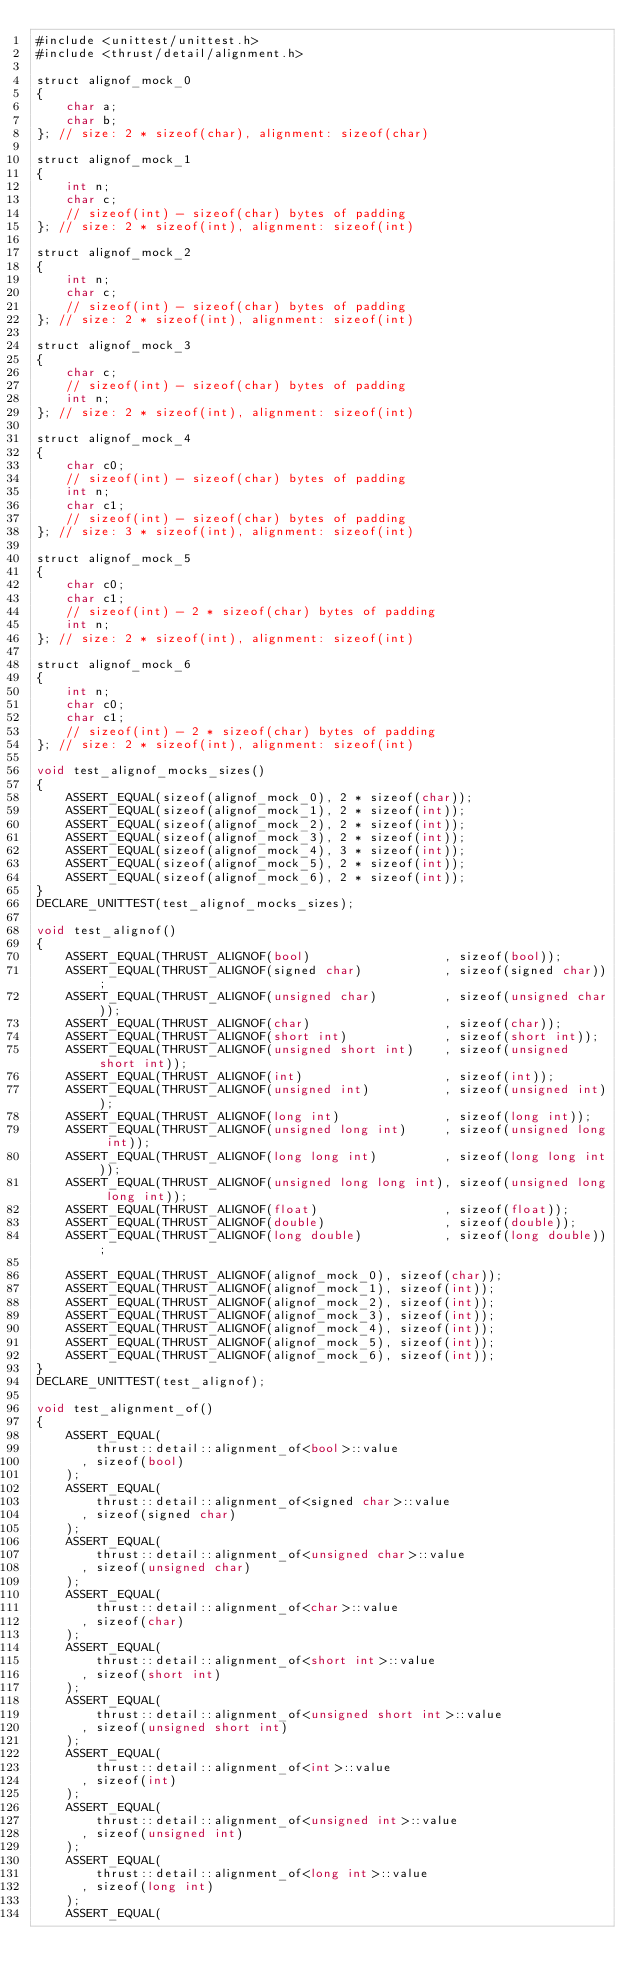<code> <loc_0><loc_0><loc_500><loc_500><_Cuda_>#include <unittest/unittest.h>
#include <thrust/detail/alignment.h>

struct alignof_mock_0
{
    char a;
    char b;
}; // size: 2 * sizeof(char), alignment: sizeof(char)

struct alignof_mock_1
{
    int n;
    char c;
    // sizeof(int) - sizeof(char) bytes of padding
}; // size: 2 * sizeof(int), alignment: sizeof(int)

struct alignof_mock_2
{
    int n;
    char c;
    // sizeof(int) - sizeof(char) bytes of padding
}; // size: 2 * sizeof(int), alignment: sizeof(int)

struct alignof_mock_3
{
    char c;
    // sizeof(int) - sizeof(char) bytes of padding
    int n;
}; // size: 2 * sizeof(int), alignment: sizeof(int)

struct alignof_mock_4
{
    char c0;
    // sizeof(int) - sizeof(char) bytes of padding
    int n;
    char c1;
    // sizeof(int) - sizeof(char) bytes of padding
}; // size: 3 * sizeof(int), alignment: sizeof(int)

struct alignof_mock_5
{
    char c0;
    char c1;
    // sizeof(int) - 2 * sizeof(char) bytes of padding
    int n;
}; // size: 2 * sizeof(int), alignment: sizeof(int)

struct alignof_mock_6
{
    int n;
    char c0;
    char c1;
    // sizeof(int) - 2 * sizeof(char) bytes of padding
}; // size: 2 * sizeof(int), alignment: sizeof(int)

void test_alignof_mocks_sizes()
{
    ASSERT_EQUAL(sizeof(alignof_mock_0), 2 * sizeof(char));
    ASSERT_EQUAL(sizeof(alignof_mock_1), 2 * sizeof(int));
    ASSERT_EQUAL(sizeof(alignof_mock_2), 2 * sizeof(int));
    ASSERT_EQUAL(sizeof(alignof_mock_3), 2 * sizeof(int));
    ASSERT_EQUAL(sizeof(alignof_mock_4), 3 * sizeof(int));
    ASSERT_EQUAL(sizeof(alignof_mock_5), 2 * sizeof(int));
    ASSERT_EQUAL(sizeof(alignof_mock_6), 2 * sizeof(int));
}
DECLARE_UNITTEST(test_alignof_mocks_sizes);

void test_alignof()
{
    ASSERT_EQUAL(THRUST_ALIGNOF(bool)                  , sizeof(bool));
    ASSERT_EQUAL(THRUST_ALIGNOF(signed char)           , sizeof(signed char));
    ASSERT_EQUAL(THRUST_ALIGNOF(unsigned char)         , sizeof(unsigned char));
    ASSERT_EQUAL(THRUST_ALIGNOF(char)                  , sizeof(char));
    ASSERT_EQUAL(THRUST_ALIGNOF(short int)             , sizeof(short int));
    ASSERT_EQUAL(THRUST_ALIGNOF(unsigned short int)    , sizeof(unsigned short int));
    ASSERT_EQUAL(THRUST_ALIGNOF(int)                   , sizeof(int));
    ASSERT_EQUAL(THRUST_ALIGNOF(unsigned int)          , sizeof(unsigned int));
    ASSERT_EQUAL(THRUST_ALIGNOF(long int)              , sizeof(long int));
    ASSERT_EQUAL(THRUST_ALIGNOF(unsigned long int)     , sizeof(unsigned long int));
    ASSERT_EQUAL(THRUST_ALIGNOF(long long int)         , sizeof(long long int));
    ASSERT_EQUAL(THRUST_ALIGNOF(unsigned long long int), sizeof(unsigned long long int));
    ASSERT_EQUAL(THRUST_ALIGNOF(float)                 , sizeof(float));
    ASSERT_EQUAL(THRUST_ALIGNOF(double)                , sizeof(double));
    ASSERT_EQUAL(THRUST_ALIGNOF(long double)           , sizeof(long double));

    ASSERT_EQUAL(THRUST_ALIGNOF(alignof_mock_0), sizeof(char));
    ASSERT_EQUAL(THRUST_ALIGNOF(alignof_mock_1), sizeof(int));
    ASSERT_EQUAL(THRUST_ALIGNOF(alignof_mock_2), sizeof(int));
    ASSERT_EQUAL(THRUST_ALIGNOF(alignof_mock_3), sizeof(int));
    ASSERT_EQUAL(THRUST_ALIGNOF(alignof_mock_4), sizeof(int));
    ASSERT_EQUAL(THRUST_ALIGNOF(alignof_mock_5), sizeof(int));
    ASSERT_EQUAL(THRUST_ALIGNOF(alignof_mock_6), sizeof(int));
}
DECLARE_UNITTEST(test_alignof);

void test_alignment_of()
{
    ASSERT_EQUAL(
        thrust::detail::alignment_of<bool>::value
      , sizeof(bool)
    );
    ASSERT_EQUAL(
        thrust::detail::alignment_of<signed char>::value
      , sizeof(signed char)
    );
    ASSERT_EQUAL(
        thrust::detail::alignment_of<unsigned char>::value
      , sizeof(unsigned char)
    );
    ASSERT_EQUAL(
        thrust::detail::alignment_of<char>::value
      , sizeof(char)
    );
    ASSERT_EQUAL(
        thrust::detail::alignment_of<short int>::value
      , sizeof(short int)
    );
    ASSERT_EQUAL(
        thrust::detail::alignment_of<unsigned short int>::value
      , sizeof(unsigned short int)
    );
    ASSERT_EQUAL(
        thrust::detail::alignment_of<int>::value
      , sizeof(int)
    );
    ASSERT_EQUAL(
        thrust::detail::alignment_of<unsigned int>::value
      , sizeof(unsigned int)
    );
    ASSERT_EQUAL(
        thrust::detail::alignment_of<long int>::value
      , sizeof(long int)
    );
    ASSERT_EQUAL(</code> 